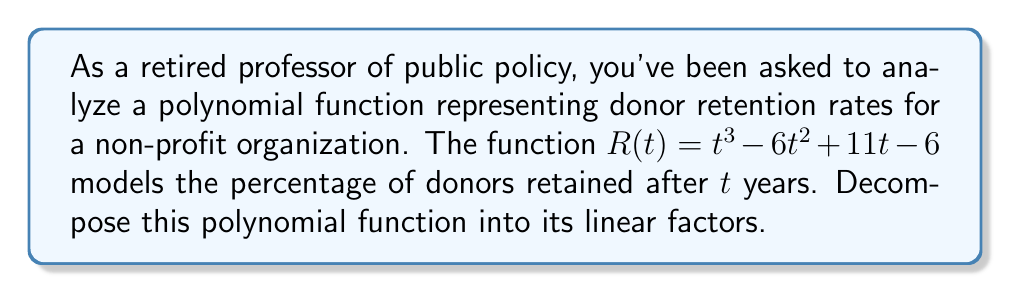Could you help me with this problem? To decompose the polynomial function $R(t) = t^3 - 6t^2 + 11t - 6$ into its linear factors, we'll follow these steps:

1) First, let's check if there are any rational roots using the rational root theorem. The possible rational roots are the factors of the constant term (6): ±1, ±2, ±3, ±6.

2) Testing these values, we find that $R(1) = 0$. So $(t-1)$ is a factor.

3) We can use polynomial long division to divide $R(t)$ by $(t-1)$:

   $$t^3 - 6t^2 + 11t - 6 = (t-1)(t^2 - 5t + 6)$$

4) Now we need to factor the quadratic term $t^2 - 5t + 6$. We can do this by finding two numbers that multiply to give 6 and add to give -5. These numbers are -2 and -3.

5) Therefore, $t^2 - 5t + 6 = (t-2)(t-3)$

6) Combining all factors, we get:

   $$R(t) = (t-1)(t-2)(t-3)$$

This decomposition shows that the donor retention rate reaches zero after 1, 2, and 3 years, which could represent different segments of donors with varying loyalty levels.
Answer: $R(t) = (t-1)(t-2)(t-3)$ 